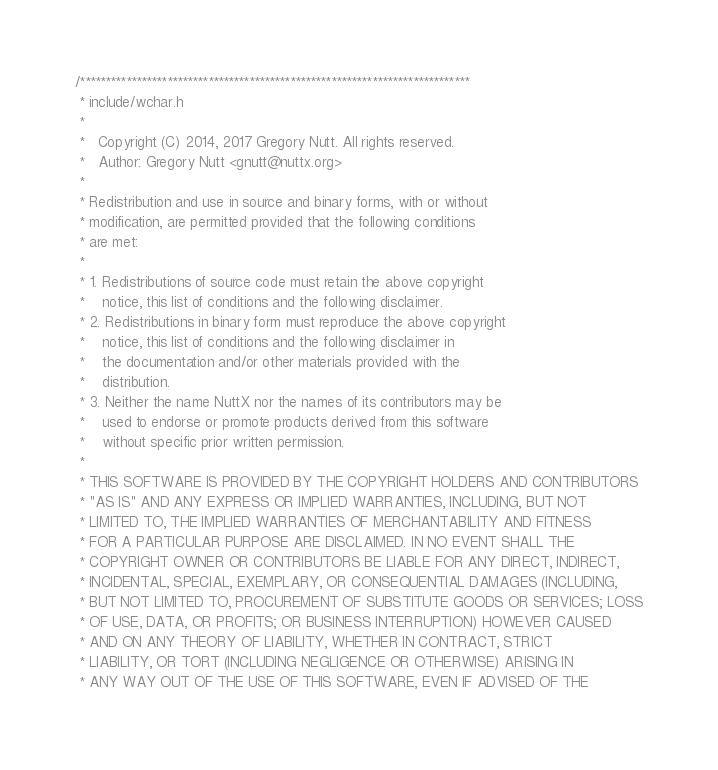<code> <loc_0><loc_0><loc_500><loc_500><_C_>/****************************************************************************
 * include/wchar.h
 *
 *   Copyright (C) 2014, 2017 Gregory Nutt. All rights reserved.
 *   Author: Gregory Nutt <gnutt@nuttx.org>
 *
 * Redistribution and use in source and binary forms, with or without
 * modification, are permitted provided that the following conditions
 * are met:
 *
 * 1. Redistributions of source code must retain the above copyright
 *    notice, this list of conditions and the following disclaimer.
 * 2. Redistributions in binary form must reproduce the above copyright
 *    notice, this list of conditions and the following disclaimer in
 *    the documentation and/or other materials provided with the
 *    distribution.
 * 3. Neither the name NuttX nor the names of its contributors may be
 *    used to endorse or promote products derived from this software
 *    without specific prior written permission.
 *
 * THIS SOFTWARE IS PROVIDED BY THE COPYRIGHT HOLDERS AND CONTRIBUTORS
 * "AS IS" AND ANY EXPRESS OR IMPLIED WARRANTIES, INCLUDING, BUT NOT
 * LIMITED TO, THE IMPLIED WARRANTIES OF MERCHANTABILITY AND FITNESS
 * FOR A PARTICULAR PURPOSE ARE DISCLAIMED. IN NO EVENT SHALL THE
 * COPYRIGHT OWNER OR CONTRIBUTORS BE LIABLE FOR ANY DIRECT, INDIRECT,
 * INCIDENTAL, SPECIAL, EXEMPLARY, OR CONSEQUENTIAL DAMAGES (INCLUDING,
 * BUT NOT LIMITED TO, PROCUREMENT OF SUBSTITUTE GOODS OR SERVICES; LOSS
 * OF USE, DATA, OR PROFITS; OR BUSINESS INTERRUPTION) HOWEVER CAUSED
 * AND ON ANY THEORY OF LIABILITY, WHETHER IN CONTRACT, STRICT
 * LIABILITY, OR TORT (INCLUDING NEGLIGENCE OR OTHERWISE) ARISING IN
 * ANY WAY OUT OF THE USE OF THIS SOFTWARE, EVEN IF ADVISED OF THE</code> 